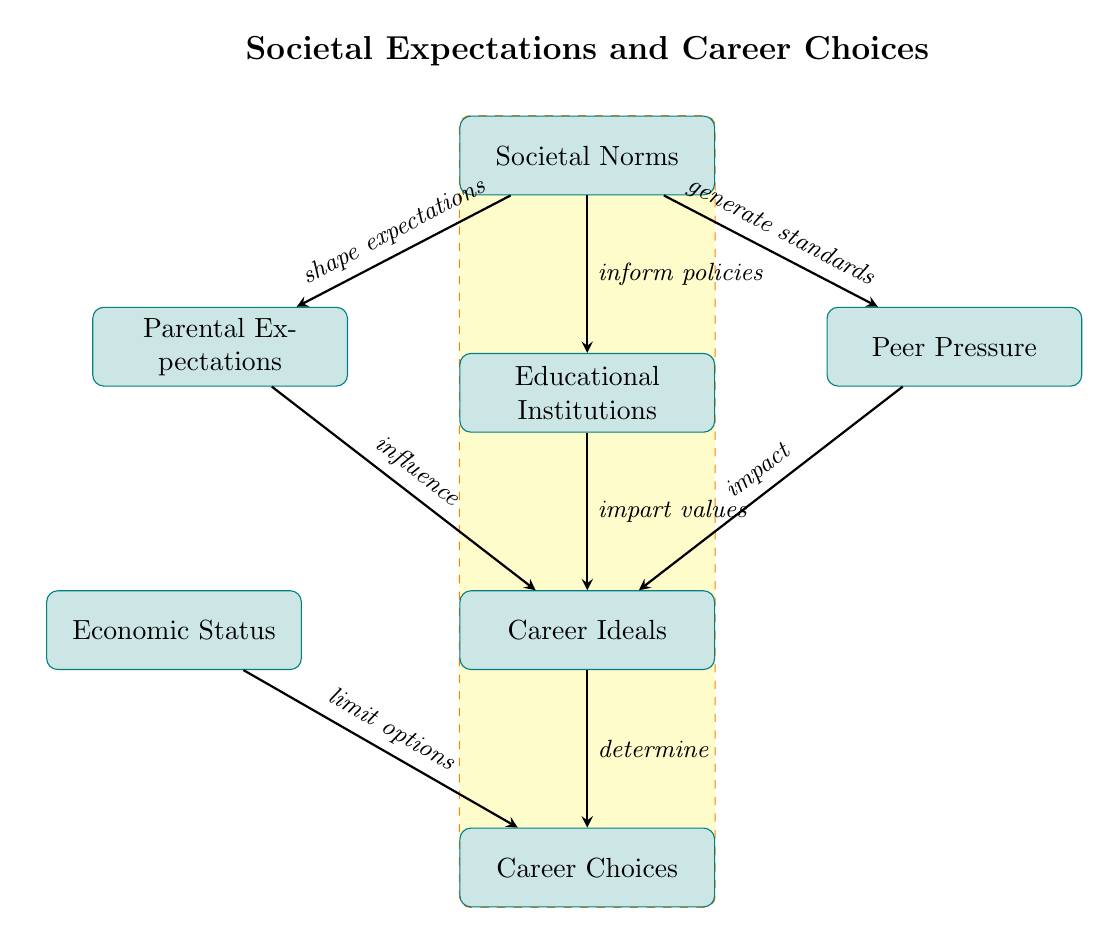What is the top node in the diagram? The top node represents the overarching theme of the diagram, which is "Societal Norms" and serves as the starting point for the flow of influence in the diagram.
Answer: Societal Norms How many main branches emerge from "Societal Norms"? The diagram shows three main branches that emerge from "Societal Norms," which are "Parental Expectations," "Educational Institutions," and "Peer Pressure."
Answer: 3 What does "Parental Expectations" influence? "Parental Expectations" specifically influences the next node down in the flow, which is "Career Ideals."
Answer: Career Ideals How does "Economic Status" affect "Career Choices"? "Economic Status" limits the options available for individuals when making "Career Choices," indicating that one's financial background plays a significant role in their decision-making process regarding careers.
Answer: limit options Which two nodes directly influence "Career Ideals"? The nodes that influence "Career Ideals" are "Parental Expectations," "Educational Institutions," and "Peer Pressure," all of which provide varying societal inputs that shape what individuals perceive as ideal careers.
Answer: Parental Expectations and Educational Institutions What is the final node that represents actionable decisions in the diagram? The final node represents the culmination of influences and ideals, specifically showcasing the resultant decisions from all preceding factors, labeled as "Career Choices."
Answer: Career Choices What common theme unifies the arrows in this diagram? The theme unifying the arrows in this diagram is the influence of various societal aspects, leading from the broader "Societal Norms" to more specific personal outcomes like "Career Choices."
Answer: influence How do "Educational Institutions" shape "Career Ideals"? "Educational Institutions" impart values that directly shape "Career Ideals," meaning the educational environment and teachings contribute to what individuals view as desirable professions.
Answer: impart values 